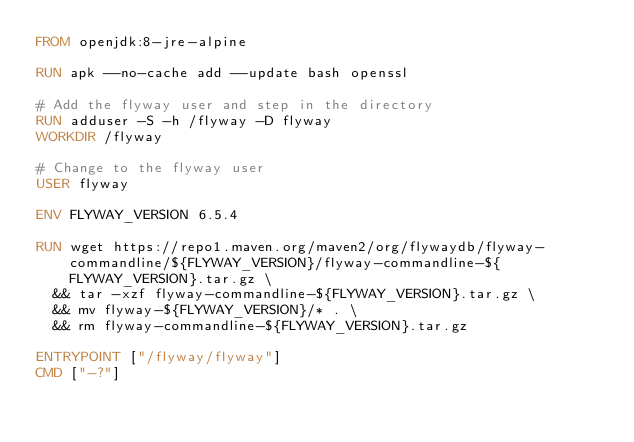<code> <loc_0><loc_0><loc_500><loc_500><_Dockerfile_>FROM openjdk:8-jre-alpine

RUN apk --no-cache add --update bash openssl

# Add the flyway user and step in the directory
RUN adduser -S -h /flyway -D flyway
WORKDIR /flyway

# Change to the flyway user
USER flyway

ENV FLYWAY_VERSION 6.5.4

RUN wget https://repo1.maven.org/maven2/org/flywaydb/flyway-commandline/${FLYWAY_VERSION}/flyway-commandline-${FLYWAY_VERSION}.tar.gz \
  && tar -xzf flyway-commandline-${FLYWAY_VERSION}.tar.gz \
  && mv flyway-${FLYWAY_VERSION}/* . \
  && rm flyway-commandline-${FLYWAY_VERSION}.tar.gz

ENTRYPOINT ["/flyway/flyway"]
CMD ["-?"]
</code> 